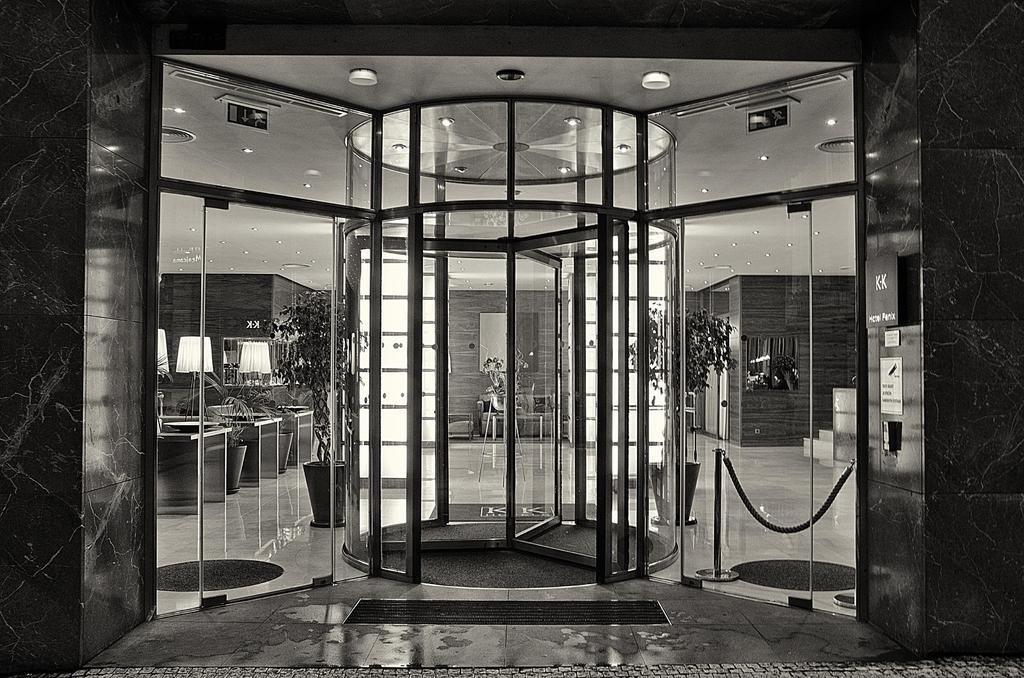What is the color scheme of the image? The image is black and white. What type of space is depicted in the image? The image shows an inner view of a room. What kind of objects can be seen in the room? There are plants and chairs in the room. What is the source of illumination in the room? There are lights in the room. What part of the room is visible at the top of the image? The ceiling with lights is visible at the top of the image. What type of duck can be seen participating in the protest in the image? There is no duck or protest present in the image; it shows an inner view of a room with plants, chairs, and lights. 